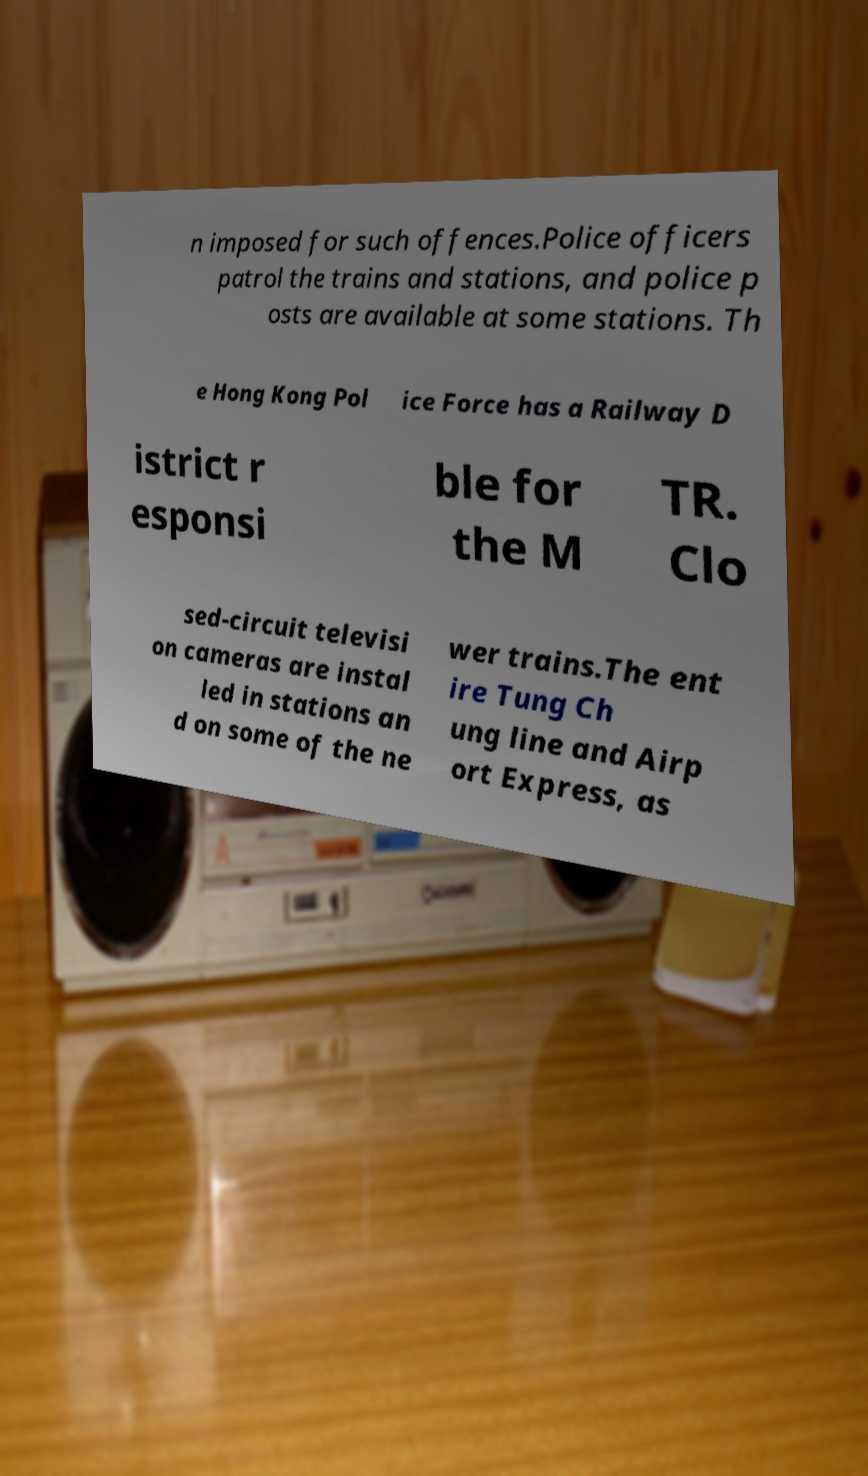For documentation purposes, I need the text within this image transcribed. Could you provide that? n imposed for such offences.Police officers patrol the trains and stations, and police p osts are available at some stations. Th e Hong Kong Pol ice Force has a Railway D istrict r esponsi ble for the M TR. Clo sed-circuit televisi on cameras are instal led in stations an d on some of the ne wer trains.The ent ire Tung Ch ung line and Airp ort Express, as 